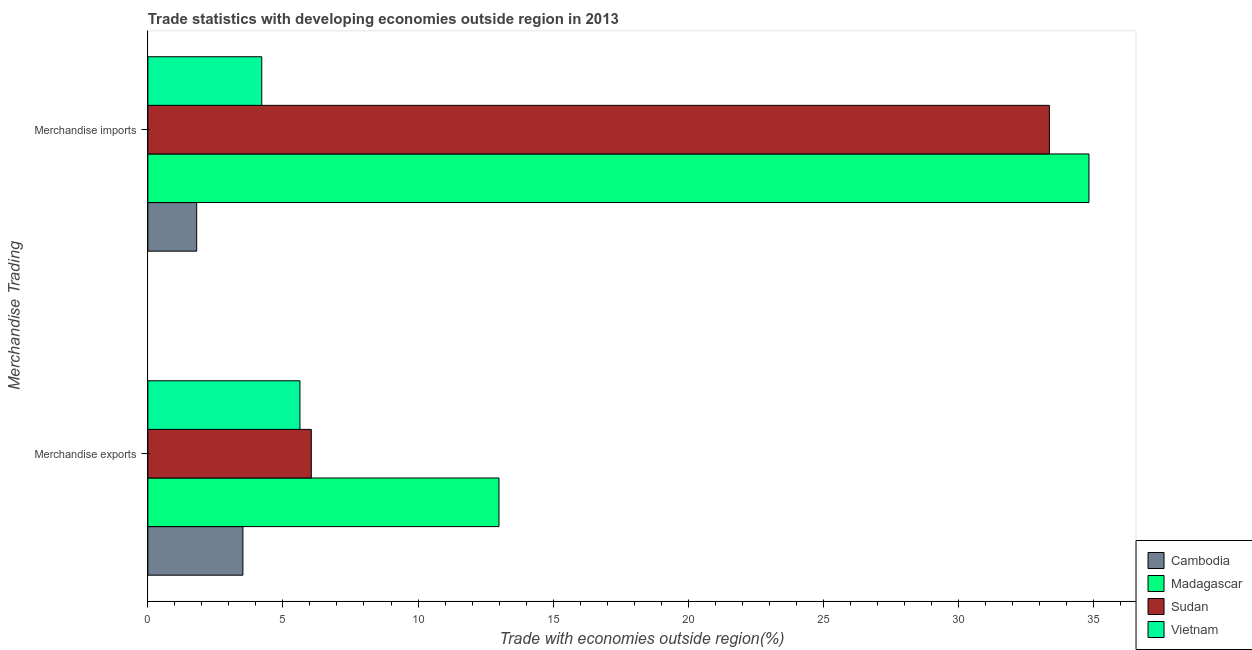How many different coloured bars are there?
Provide a short and direct response. 4. How many groups of bars are there?
Provide a short and direct response. 2. Are the number of bars per tick equal to the number of legend labels?
Your answer should be compact. Yes. Are the number of bars on each tick of the Y-axis equal?
Give a very brief answer. Yes. What is the label of the 2nd group of bars from the top?
Your response must be concise. Merchandise exports. What is the merchandise imports in Vietnam?
Your response must be concise. 4.22. Across all countries, what is the maximum merchandise exports?
Offer a very short reply. 13. Across all countries, what is the minimum merchandise imports?
Provide a succinct answer. 1.81. In which country was the merchandise imports maximum?
Provide a succinct answer. Madagascar. In which country was the merchandise exports minimum?
Provide a succinct answer. Cambodia. What is the total merchandise imports in the graph?
Your response must be concise. 74.23. What is the difference between the merchandise exports in Cambodia and that in Vietnam?
Provide a succinct answer. -2.11. What is the difference between the merchandise imports in Madagascar and the merchandise exports in Sudan?
Provide a short and direct response. 28.79. What is the average merchandise exports per country?
Ensure brevity in your answer.  7.05. What is the difference between the merchandise imports and merchandise exports in Madagascar?
Offer a very short reply. 21.84. What is the ratio of the merchandise imports in Sudan to that in Vietnam?
Provide a succinct answer. 7.92. What does the 3rd bar from the top in Merchandise exports represents?
Ensure brevity in your answer.  Madagascar. What does the 2nd bar from the bottom in Merchandise exports represents?
Your answer should be very brief. Madagascar. How many countries are there in the graph?
Keep it short and to the point. 4. Are the values on the major ticks of X-axis written in scientific E-notation?
Make the answer very short. No. What is the title of the graph?
Make the answer very short. Trade statistics with developing economies outside region in 2013. Does "Tuvalu" appear as one of the legend labels in the graph?
Keep it short and to the point. No. What is the label or title of the X-axis?
Keep it short and to the point. Trade with economies outside region(%). What is the label or title of the Y-axis?
Provide a succinct answer. Merchandise Trading. What is the Trade with economies outside region(%) of Cambodia in Merchandise exports?
Offer a very short reply. 3.52. What is the Trade with economies outside region(%) in Madagascar in Merchandise exports?
Offer a terse response. 13. What is the Trade with economies outside region(%) in Sudan in Merchandise exports?
Your response must be concise. 6.05. What is the Trade with economies outside region(%) of Vietnam in Merchandise exports?
Your response must be concise. 5.63. What is the Trade with economies outside region(%) in Cambodia in Merchandise imports?
Offer a terse response. 1.81. What is the Trade with economies outside region(%) in Madagascar in Merchandise imports?
Provide a succinct answer. 34.84. What is the Trade with economies outside region(%) of Sudan in Merchandise imports?
Offer a terse response. 33.37. What is the Trade with economies outside region(%) in Vietnam in Merchandise imports?
Offer a very short reply. 4.22. Across all Merchandise Trading, what is the maximum Trade with economies outside region(%) of Cambodia?
Offer a terse response. 3.52. Across all Merchandise Trading, what is the maximum Trade with economies outside region(%) of Madagascar?
Keep it short and to the point. 34.84. Across all Merchandise Trading, what is the maximum Trade with economies outside region(%) in Sudan?
Your answer should be very brief. 33.37. Across all Merchandise Trading, what is the maximum Trade with economies outside region(%) in Vietnam?
Offer a terse response. 5.63. Across all Merchandise Trading, what is the minimum Trade with economies outside region(%) of Cambodia?
Your answer should be compact. 1.81. Across all Merchandise Trading, what is the minimum Trade with economies outside region(%) of Madagascar?
Keep it short and to the point. 13. Across all Merchandise Trading, what is the minimum Trade with economies outside region(%) in Sudan?
Provide a succinct answer. 6.05. Across all Merchandise Trading, what is the minimum Trade with economies outside region(%) of Vietnam?
Provide a short and direct response. 4.22. What is the total Trade with economies outside region(%) of Cambodia in the graph?
Your answer should be very brief. 5.32. What is the total Trade with economies outside region(%) in Madagascar in the graph?
Your answer should be compact. 47.83. What is the total Trade with economies outside region(%) of Sudan in the graph?
Your answer should be compact. 39.42. What is the total Trade with economies outside region(%) of Vietnam in the graph?
Your response must be concise. 9.85. What is the difference between the Trade with economies outside region(%) in Cambodia in Merchandise exports and that in Merchandise imports?
Offer a very short reply. 1.71. What is the difference between the Trade with economies outside region(%) of Madagascar in Merchandise exports and that in Merchandise imports?
Make the answer very short. -21.84. What is the difference between the Trade with economies outside region(%) of Sudan in Merchandise exports and that in Merchandise imports?
Provide a succinct answer. -27.32. What is the difference between the Trade with economies outside region(%) of Vietnam in Merchandise exports and that in Merchandise imports?
Provide a short and direct response. 1.41. What is the difference between the Trade with economies outside region(%) of Cambodia in Merchandise exports and the Trade with economies outside region(%) of Madagascar in Merchandise imports?
Make the answer very short. -31.32. What is the difference between the Trade with economies outside region(%) in Cambodia in Merchandise exports and the Trade with economies outside region(%) in Sudan in Merchandise imports?
Your answer should be compact. -29.85. What is the difference between the Trade with economies outside region(%) in Cambodia in Merchandise exports and the Trade with economies outside region(%) in Vietnam in Merchandise imports?
Keep it short and to the point. -0.7. What is the difference between the Trade with economies outside region(%) of Madagascar in Merchandise exports and the Trade with economies outside region(%) of Sudan in Merchandise imports?
Keep it short and to the point. -20.37. What is the difference between the Trade with economies outside region(%) in Madagascar in Merchandise exports and the Trade with economies outside region(%) in Vietnam in Merchandise imports?
Offer a terse response. 8.78. What is the difference between the Trade with economies outside region(%) in Sudan in Merchandise exports and the Trade with economies outside region(%) in Vietnam in Merchandise imports?
Offer a very short reply. 1.83. What is the average Trade with economies outside region(%) in Cambodia per Merchandise Trading?
Your answer should be compact. 2.66. What is the average Trade with economies outside region(%) of Madagascar per Merchandise Trading?
Provide a succinct answer. 23.92. What is the average Trade with economies outside region(%) in Sudan per Merchandise Trading?
Provide a succinct answer. 19.71. What is the average Trade with economies outside region(%) of Vietnam per Merchandise Trading?
Your answer should be very brief. 4.92. What is the difference between the Trade with economies outside region(%) in Cambodia and Trade with economies outside region(%) in Madagascar in Merchandise exports?
Your response must be concise. -9.48. What is the difference between the Trade with economies outside region(%) of Cambodia and Trade with economies outside region(%) of Sudan in Merchandise exports?
Give a very brief answer. -2.53. What is the difference between the Trade with economies outside region(%) of Cambodia and Trade with economies outside region(%) of Vietnam in Merchandise exports?
Provide a succinct answer. -2.11. What is the difference between the Trade with economies outside region(%) in Madagascar and Trade with economies outside region(%) in Sudan in Merchandise exports?
Provide a succinct answer. 6.95. What is the difference between the Trade with economies outside region(%) of Madagascar and Trade with economies outside region(%) of Vietnam in Merchandise exports?
Keep it short and to the point. 7.37. What is the difference between the Trade with economies outside region(%) of Sudan and Trade with economies outside region(%) of Vietnam in Merchandise exports?
Offer a very short reply. 0.42. What is the difference between the Trade with economies outside region(%) in Cambodia and Trade with economies outside region(%) in Madagascar in Merchandise imports?
Provide a succinct answer. -33.03. What is the difference between the Trade with economies outside region(%) of Cambodia and Trade with economies outside region(%) of Sudan in Merchandise imports?
Your answer should be compact. -31.56. What is the difference between the Trade with economies outside region(%) of Cambodia and Trade with economies outside region(%) of Vietnam in Merchandise imports?
Your answer should be very brief. -2.41. What is the difference between the Trade with economies outside region(%) in Madagascar and Trade with economies outside region(%) in Sudan in Merchandise imports?
Make the answer very short. 1.47. What is the difference between the Trade with economies outside region(%) in Madagascar and Trade with economies outside region(%) in Vietnam in Merchandise imports?
Offer a very short reply. 30.62. What is the difference between the Trade with economies outside region(%) of Sudan and Trade with economies outside region(%) of Vietnam in Merchandise imports?
Offer a very short reply. 29.16. What is the ratio of the Trade with economies outside region(%) of Cambodia in Merchandise exports to that in Merchandise imports?
Offer a very short reply. 1.95. What is the ratio of the Trade with economies outside region(%) in Madagascar in Merchandise exports to that in Merchandise imports?
Give a very brief answer. 0.37. What is the ratio of the Trade with economies outside region(%) in Sudan in Merchandise exports to that in Merchandise imports?
Ensure brevity in your answer.  0.18. What is the ratio of the Trade with economies outside region(%) of Vietnam in Merchandise exports to that in Merchandise imports?
Your answer should be compact. 1.34. What is the difference between the highest and the second highest Trade with economies outside region(%) of Cambodia?
Offer a terse response. 1.71. What is the difference between the highest and the second highest Trade with economies outside region(%) in Madagascar?
Keep it short and to the point. 21.84. What is the difference between the highest and the second highest Trade with economies outside region(%) in Sudan?
Offer a very short reply. 27.32. What is the difference between the highest and the second highest Trade with economies outside region(%) in Vietnam?
Your response must be concise. 1.41. What is the difference between the highest and the lowest Trade with economies outside region(%) of Cambodia?
Your response must be concise. 1.71. What is the difference between the highest and the lowest Trade with economies outside region(%) of Madagascar?
Ensure brevity in your answer.  21.84. What is the difference between the highest and the lowest Trade with economies outside region(%) in Sudan?
Give a very brief answer. 27.32. What is the difference between the highest and the lowest Trade with economies outside region(%) of Vietnam?
Ensure brevity in your answer.  1.41. 